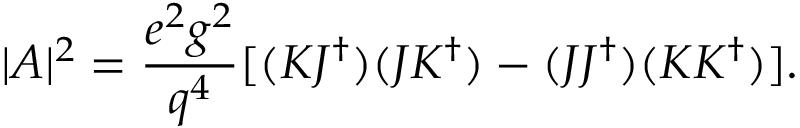<formula> <loc_0><loc_0><loc_500><loc_500>| A | ^ { 2 } = { \frac { e ^ { 2 } g ^ { 2 } } { q ^ { 4 } } } [ ( K J ^ { \dag } ) ( J K ^ { \dag } ) - ( J J ^ { \dag } ) ( K K ^ { \dag } ) ] .</formula> 